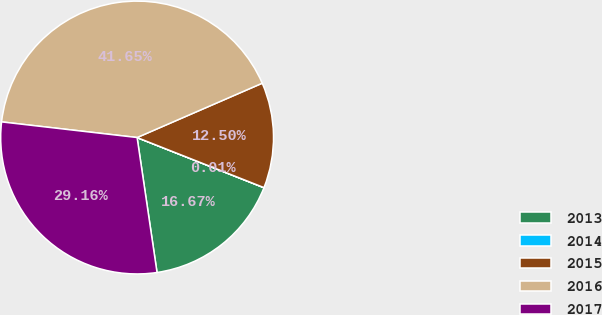Convert chart. <chart><loc_0><loc_0><loc_500><loc_500><pie_chart><fcel>2013<fcel>2014<fcel>2015<fcel>2016<fcel>2017<nl><fcel>16.67%<fcel>0.01%<fcel>12.5%<fcel>41.65%<fcel>29.16%<nl></chart> 